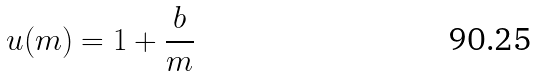Convert formula to latex. <formula><loc_0><loc_0><loc_500><loc_500>u ( m ) = 1 + \frac { b } { m }</formula> 